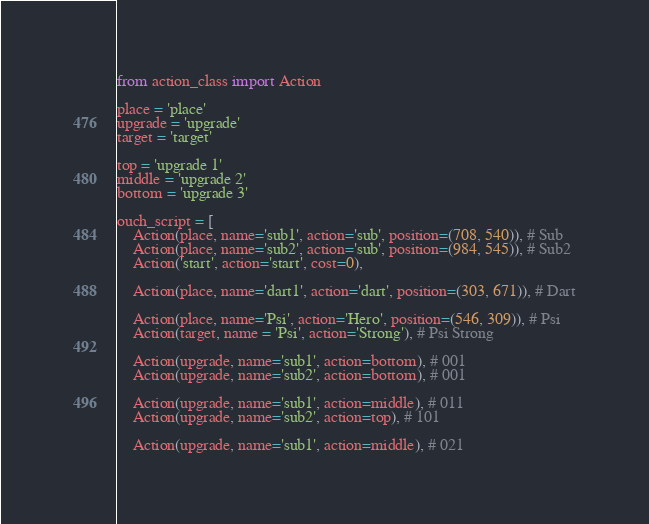<code> <loc_0><loc_0><loc_500><loc_500><_Python_>from action_class import Action

place = 'place'
upgrade = 'upgrade'
target = 'target'

top = 'upgrade 1'
middle = 'upgrade 2'
bottom = 'upgrade 3'

ouch_script = [
    Action(place, name='sub1', action='sub', position=(708, 540)), # Sub
    Action(place, name='sub2', action='sub', position=(984, 545)), # Sub2
    Action('start', action='start', cost=0),

    Action(place, name='dart1', action='dart', position=(303, 671)), # Dart

    Action(place, name='Psi', action='Hero', position=(546, 309)), # Psi
    Action(target, name = 'Psi', action='Strong'), # Psi Strong

    Action(upgrade, name='sub1', action=bottom), # 001
    Action(upgrade, name='sub2', action=bottom), # 001

    Action(upgrade, name='sub1', action=middle), # 011
    Action(upgrade, name='sub2', action=top), # 101

    Action(upgrade, name='sub1', action=middle), # 021</code> 